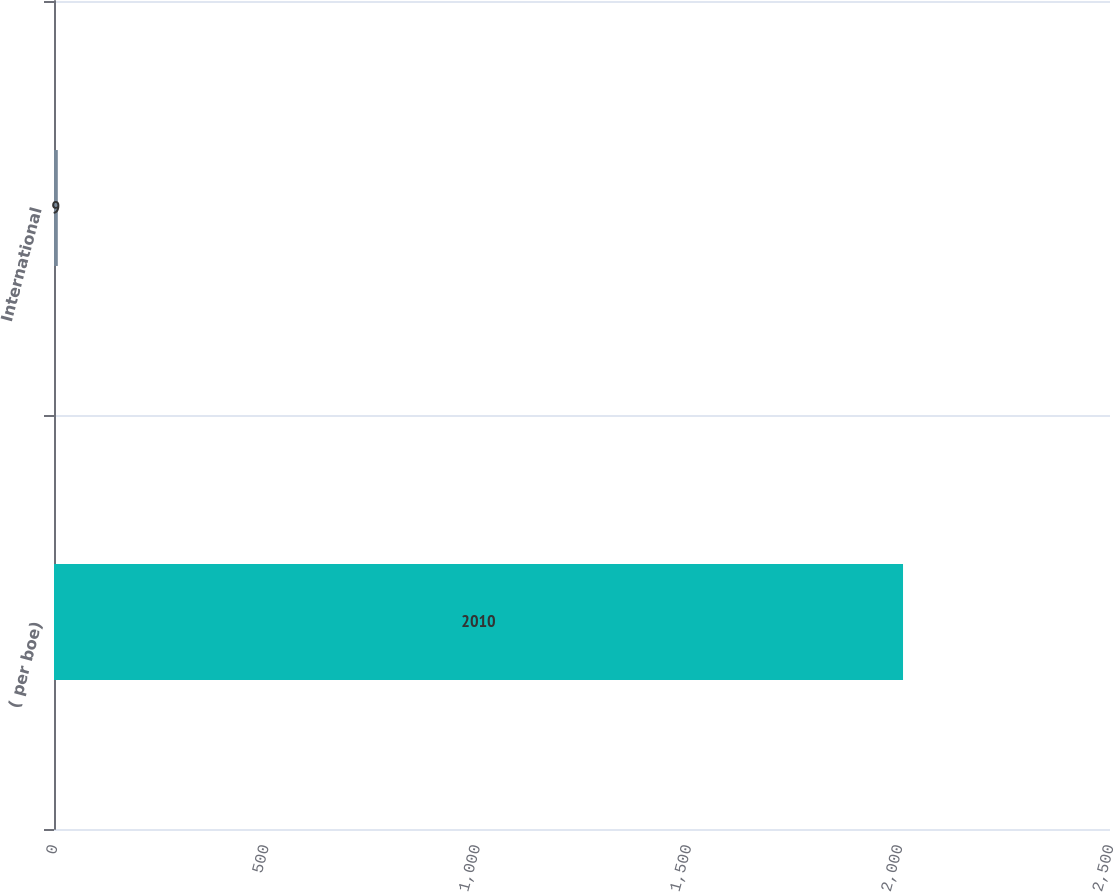<chart> <loc_0><loc_0><loc_500><loc_500><bar_chart><fcel>( per boe)<fcel>International<nl><fcel>2010<fcel>9<nl></chart> 